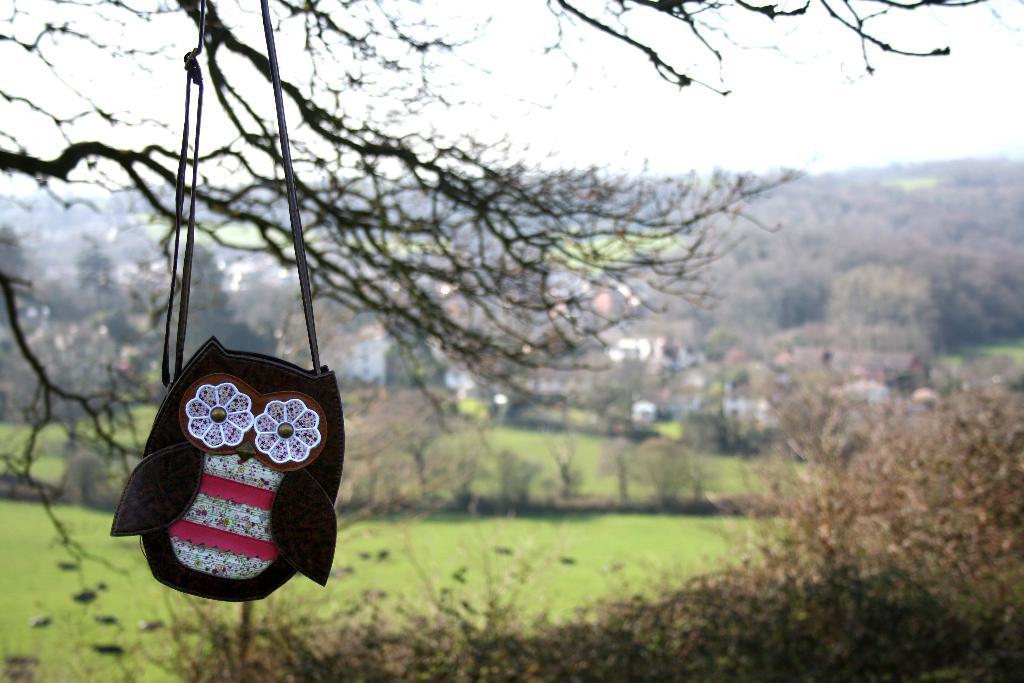In one or two sentences, can you explain what this image depicts? There is a sling bag hanging in the foreground area of the image, there are trees, houses, grassland, it seems like mountains and the sky in the background. 